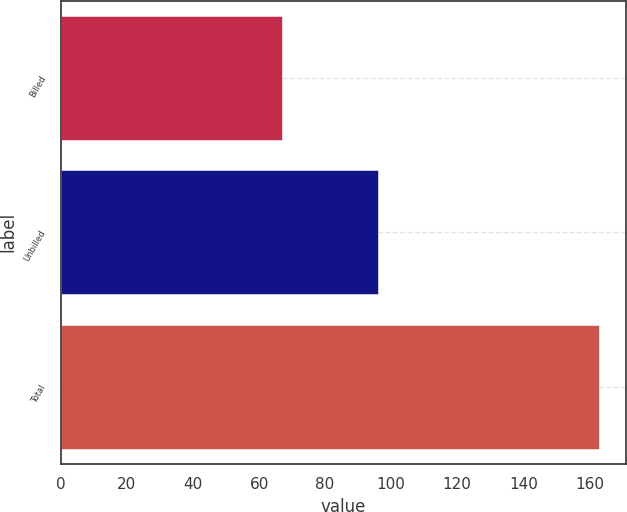Convert chart to OTSL. <chart><loc_0><loc_0><loc_500><loc_500><bar_chart><fcel>Billed<fcel>Unbilled<fcel>Total<nl><fcel>67<fcel>96<fcel>163<nl></chart> 